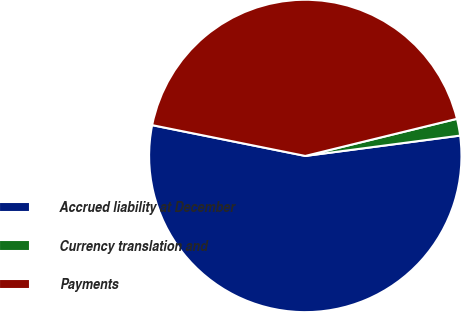Convert chart to OTSL. <chart><loc_0><loc_0><loc_500><loc_500><pie_chart><fcel>Accrued liability at December<fcel>Currency translation and<fcel>Payments<nl><fcel>55.24%<fcel>1.74%<fcel>43.02%<nl></chart> 